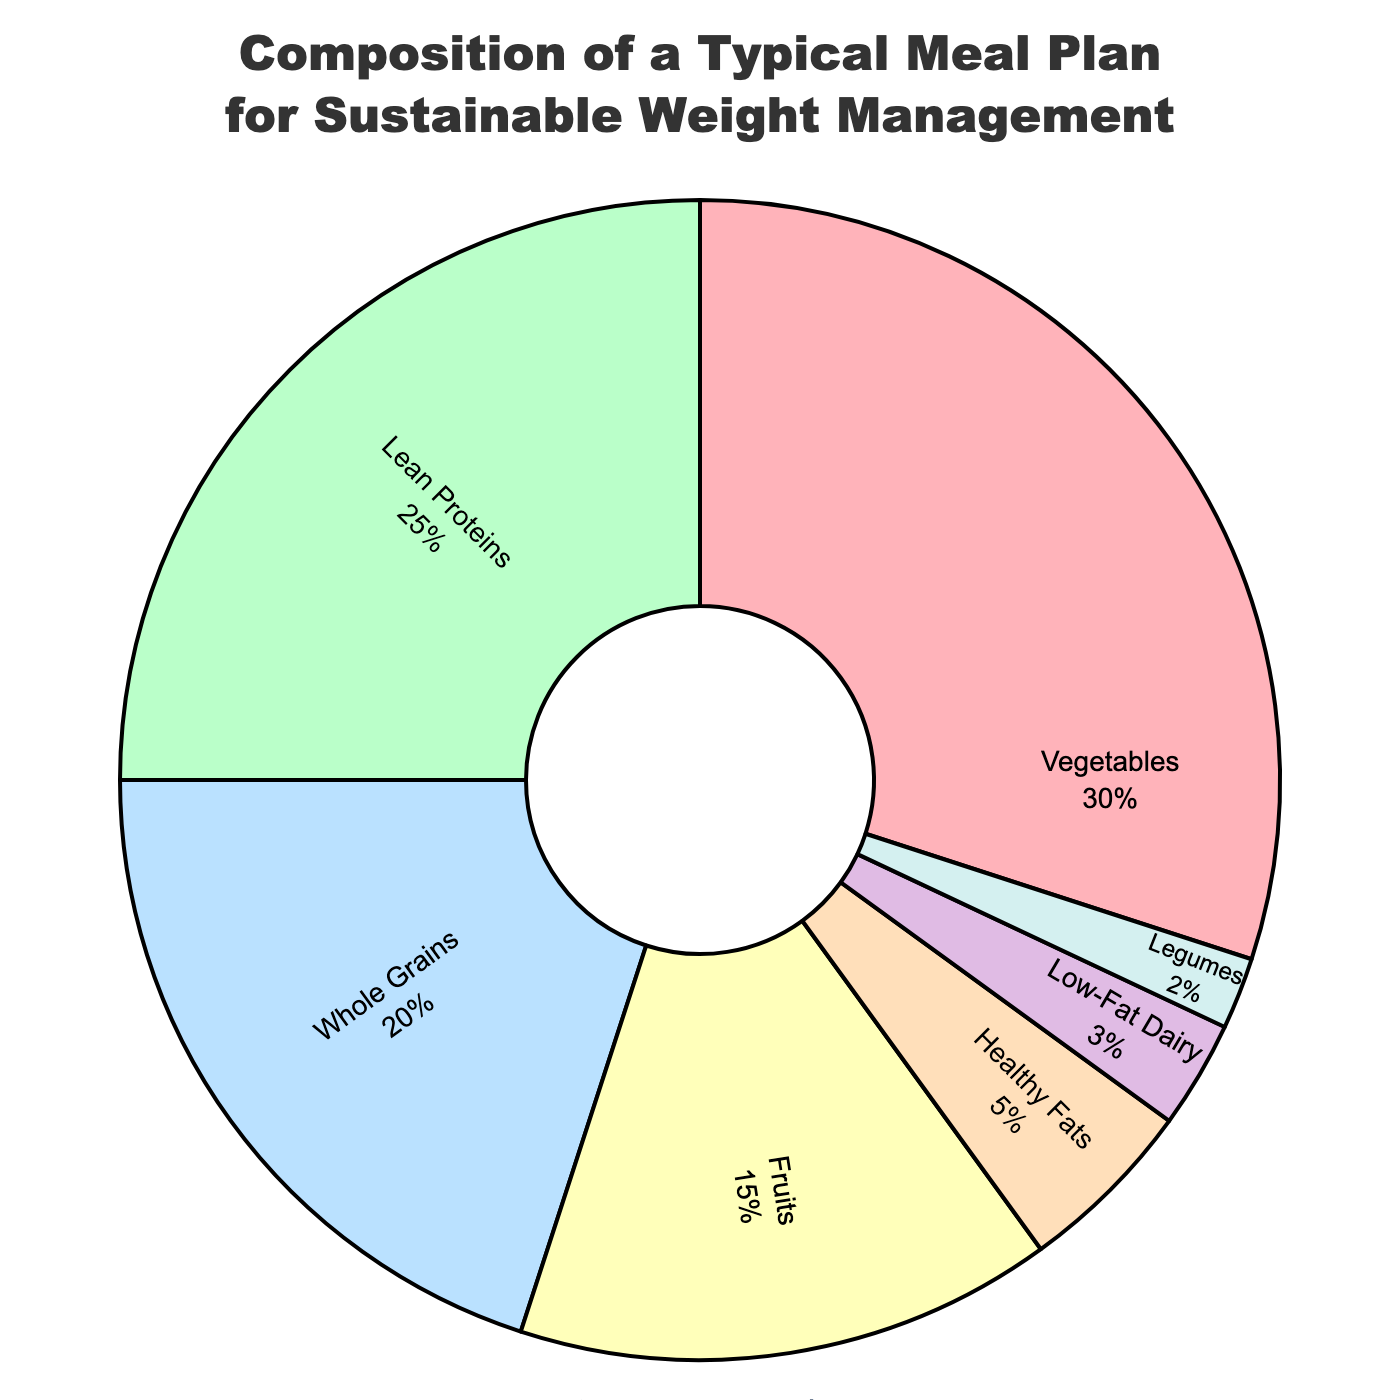What category takes up the largest percentage in the meal plan? By looking at the slices of the pie chart, the largest slice represents Vegetables. Vegetables account for 30% of the meal plan, which is the highest percentage.
Answer: Vegetables Which categories together make up more than 50% of the meal plan? Summing up the percentages of the categories in descending order until the total exceeds 50% gives: 30% (Vegetables) + 25% (Lean Proteins) = 55%. So, Vegetables and Lean Proteins together make up more than 50% of the meal plan.
Answer: Vegetables, Lean Proteins What is the difference in percentage between Whole Grains and Fruits? The percentage for Whole Grains is 20%, and for Fruits, it is 15%. The difference can be calculated as 20% - 15% = 5%.
Answer: 5% Is the percentage of Legumes greater than Low-Fat Dairy? By comparing the percentages, Legumes constitute 2% and Low-Fat Dairy constitutes 3%. Since 3% is greater than 2%, Legumes are not greater than Low-Fat Dairy.
Answer: No Which category has the smallest slice in the pie chart? Identifying the smallest slice visually, the category with the smallest percentage is Legumes, at 2%.
Answer: Legumes How much larger is the percentage of Lean Proteins compared to Healthy Fats? Lean Proteins take up 25% of the meal plan, and Healthy Fats take up 5%. The difference is calculated as 25% - 5% = 20%. Lean Proteins are 20% larger than Healthy Fats.
Answer: 20% Do Vegetables and Fruits combined cover more or less than 50% of the meal plan? Adding the percentages for Vegetables (30%) and Fruits (15%) gives a total of 45%. Since 45% is less than 50%, they cover less than 50% of the meal plan.
Answer: Less If you combine Lean Proteins and Healthy Fats, what is their total percentage? Adding the percentages for Lean Proteins (25%) and Healthy Fats (5%) gives 25% + 5% = 30%.
Answer: 30% In what order do the categories rank from highest to lowest percentage? Listing the categories based on their percentages from highest to lowest: Vegetables (30%), Lean Proteins (25%), Whole Grains (20%), Fruits (15%), Healthy Fats (5%), Low-Fat Dairy (3%), Legumes (2%).
Answer: Vegetables, Lean Proteins, Whole Grains, Fruits, Healthy Fats, Low-Fat Dairy, Legumes 